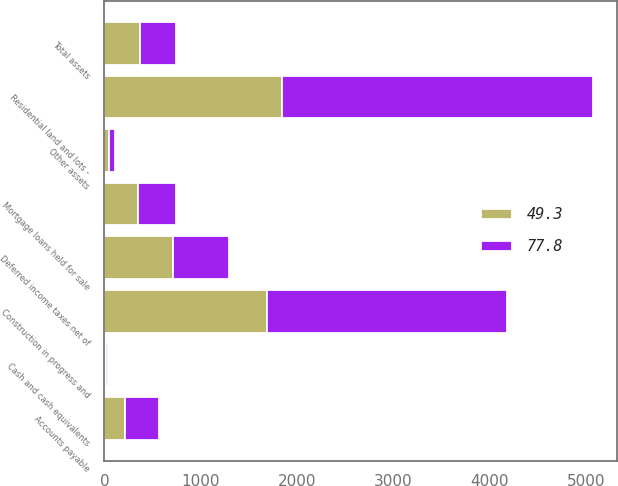<chart> <loc_0><loc_0><loc_500><loc_500><stacked_bar_chart><ecel><fcel>Construction in progress and<fcel>Residential land and lots -<fcel>Deferred income taxes net of<fcel>Cash and cash equivalents<fcel>Mortgage loans held for sale<fcel>Other assets<fcel>Total assets<fcel>Accounts payable<nl><fcel>77.8<fcel>2498<fcel>3227.3<fcel>586.6<fcel>23.2<fcel>395.1<fcel>56.9<fcel>370.75<fcel>346.4<nl><fcel>49.3<fcel>1682.7<fcel>1838.4<fcel>709.5<fcel>17.3<fcel>345.3<fcel>50.5<fcel>370.75<fcel>216.2<nl></chart> 